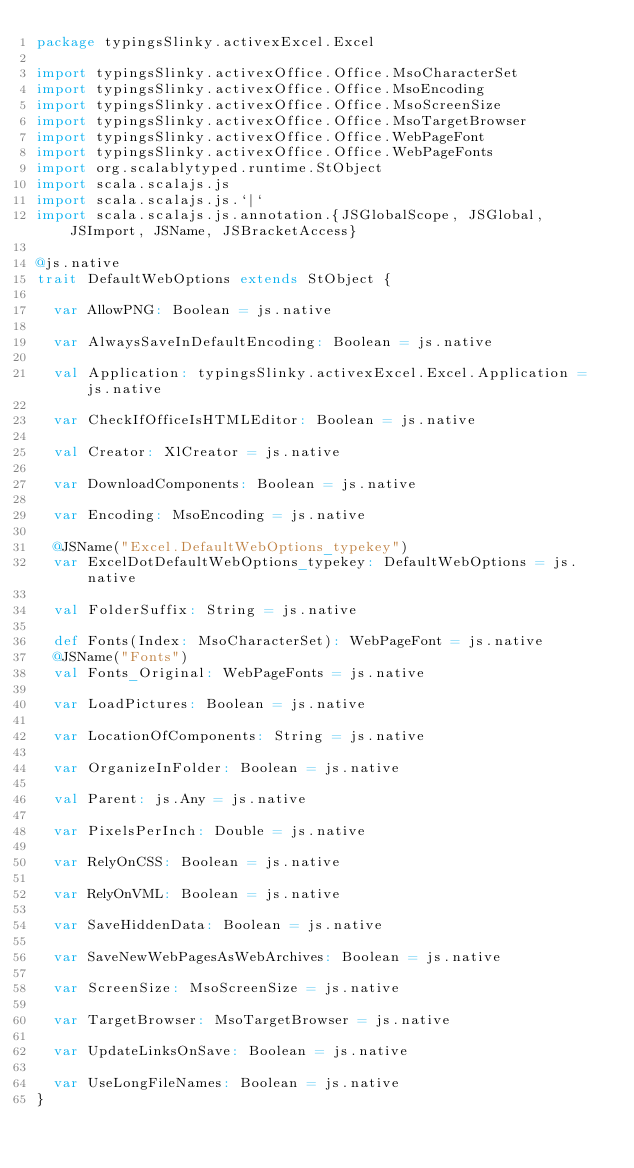<code> <loc_0><loc_0><loc_500><loc_500><_Scala_>package typingsSlinky.activexExcel.Excel

import typingsSlinky.activexOffice.Office.MsoCharacterSet
import typingsSlinky.activexOffice.Office.MsoEncoding
import typingsSlinky.activexOffice.Office.MsoScreenSize
import typingsSlinky.activexOffice.Office.MsoTargetBrowser
import typingsSlinky.activexOffice.Office.WebPageFont
import typingsSlinky.activexOffice.Office.WebPageFonts
import org.scalablytyped.runtime.StObject
import scala.scalajs.js
import scala.scalajs.js.`|`
import scala.scalajs.js.annotation.{JSGlobalScope, JSGlobal, JSImport, JSName, JSBracketAccess}

@js.native
trait DefaultWebOptions extends StObject {
  
  var AllowPNG: Boolean = js.native
  
  var AlwaysSaveInDefaultEncoding: Boolean = js.native
  
  val Application: typingsSlinky.activexExcel.Excel.Application = js.native
  
  var CheckIfOfficeIsHTMLEditor: Boolean = js.native
  
  val Creator: XlCreator = js.native
  
  var DownloadComponents: Boolean = js.native
  
  var Encoding: MsoEncoding = js.native
  
  @JSName("Excel.DefaultWebOptions_typekey")
  var ExcelDotDefaultWebOptions_typekey: DefaultWebOptions = js.native
  
  val FolderSuffix: String = js.native
  
  def Fonts(Index: MsoCharacterSet): WebPageFont = js.native
  @JSName("Fonts")
  val Fonts_Original: WebPageFonts = js.native
  
  var LoadPictures: Boolean = js.native
  
  var LocationOfComponents: String = js.native
  
  var OrganizeInFolder: Boolean = js.native
  
  val Parent: js.Any = js.native
  
  var PixelsPerInch: Double = js.native
  
  var RelyOnCSS: Boolean = js.native
  
  var RelyOnVML: Boolean = js.native
  
  var SaveHiddenData: Boolean = js.native
  
  var SaveNewWebPagesAsWebArchives: Boolean = js.native
  
  var ScreenSize: MsoScreenSize = js.native
  
  var TargetBrowser: MsoTargetBrowser = js.native
  
  var UpdateLinksOnSave: Boolean = js.native
  
  var UseLongFileNames: Boolean = js.native
}
</code> 